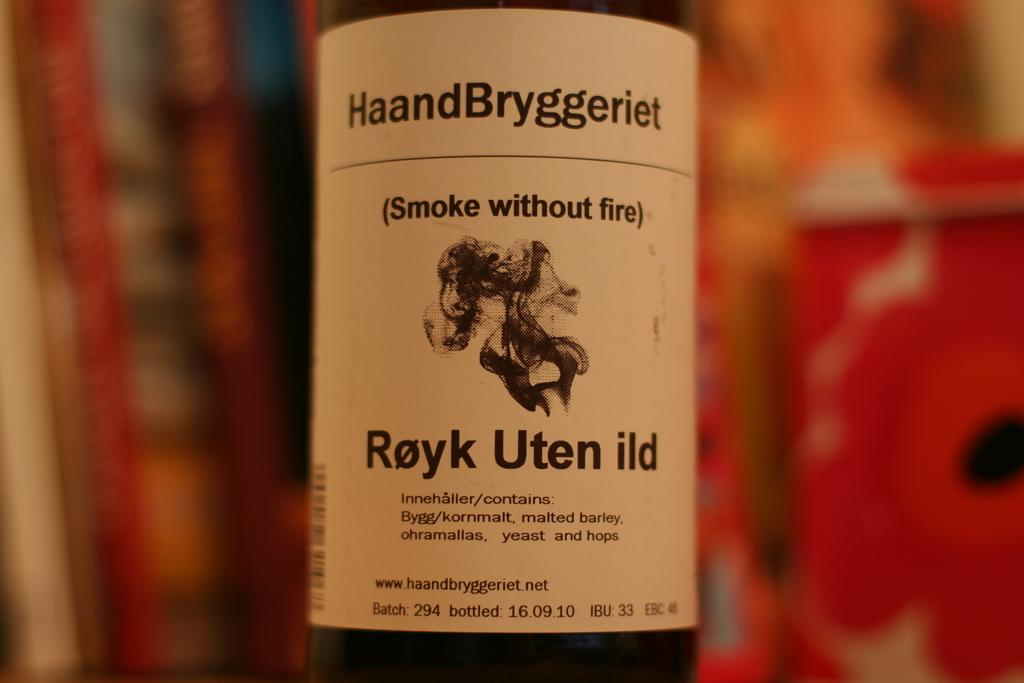Provide a one-sentence caption for the provided image. HaandBryggeriet Royk Uten ild smoke without fire bottle. 